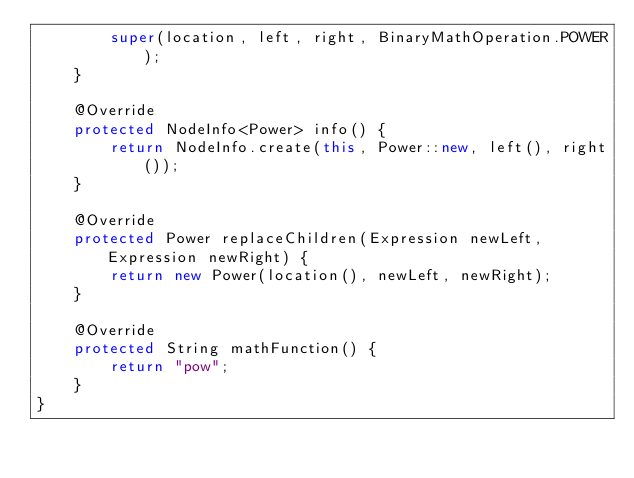Convert code to text. <code><loc_0><loc_0><loc_500><loc_500><_Java_>        super(location, left, right, BinaryMathOperation.POWER);
    }

    @Override
    protected NodeInfo<Power> info() {
        return NodeInfo.create(this, Power::new, left(), right());
    }

    @Override
    protected Power replaceChildren(Expression newLeft, Expression newRight) {
        return new Power(location(), newLeft, newRight);
    }

    @Override
    protected String mathFunction() {
        return "pow";
    }
}
</code> 